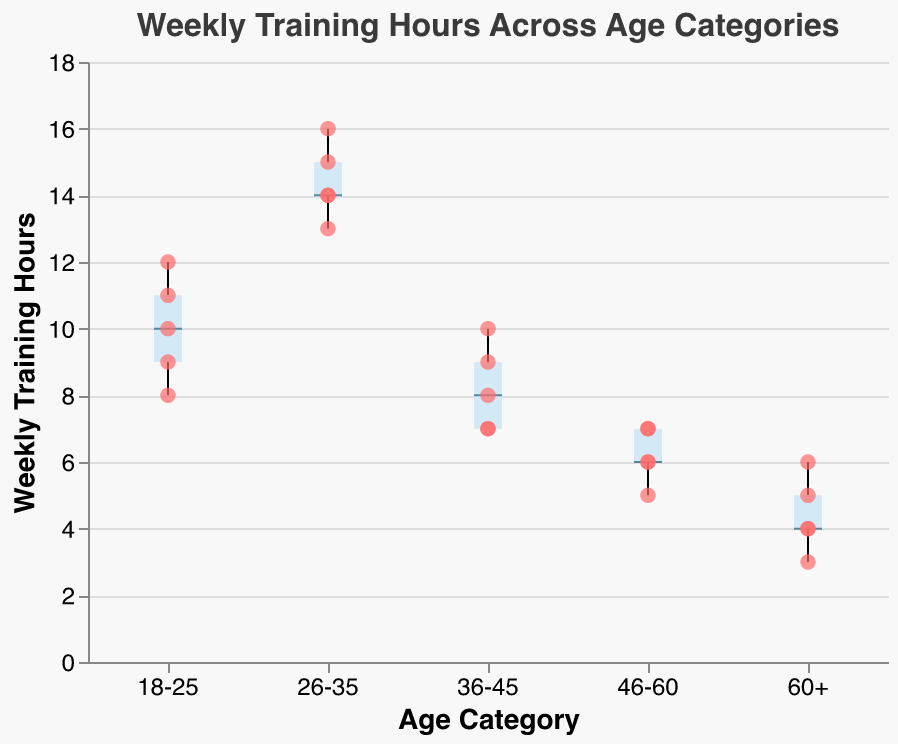What is the title of the plot? The title is given at the top of the plot. It reads "Weekly Training Hours Across Age Categories".
Answer: Weekly Training Hours Across Age Categories What do the X and Y axes represent? The X axis represents the Age Category of the runners, while the Y axis represents the Weekly Training Hours.
Answer: Age Category, Weekly Training Hours Which Age Category has the highest median weekly training hours? Look for the horizontal line inside the box for each age category. The 26-35 category has the highest median.
Answer: 26-35 How many runners are there in the 46-60 Age Category data? Count the scatter points over the boxplot for the 46-60 group. There are 5 points.
Answer: 5 What is the range of the Weekly Training Hours for the 18-25 Age Category? The vertical distance between the whiskers for the 18-25 category shows the range, which is from 8 to 12 hours.
Answer: 8 to 12 hours Which Age Category has the least variability in Weekly Training Hours? Look for the smallest distance between the whiskers. The 60+ category has the smallest range (3 to 6 hours).
Answer: 60+ Who is the runner that trains the most weekly in the 60+ Age Category? The tooltip visible on the scatter points will show the runner's name with the highest weekly training hours in that category. Linda trains the most with 6 hours.
Answer: Linda What is the median Weekly Training Hours for the 36-45 Age Category? The horizontal line inside the box for the 36-45 category shows the median, which is 8 hours.
Answer: 8 hours Compare the median Weekly Training Hours between the 26-35 and 46-60 Age Categories. Look at the horizontal lines inside the boxes for both categories. The 26-35 category has a higher median (14 hours) compared to 46-60 (6 hours).
Answer: 26-35: 14 hours, 46-60: 6 hours What is the interquartile range (IQR) for the 18-25 Age Category? The IQR is the distance between the box edges (Q1 and Q3). For 18-25, it ranges from 9 to 11 hours, so the IQR is 2 hours.
Answer: 2 hours 